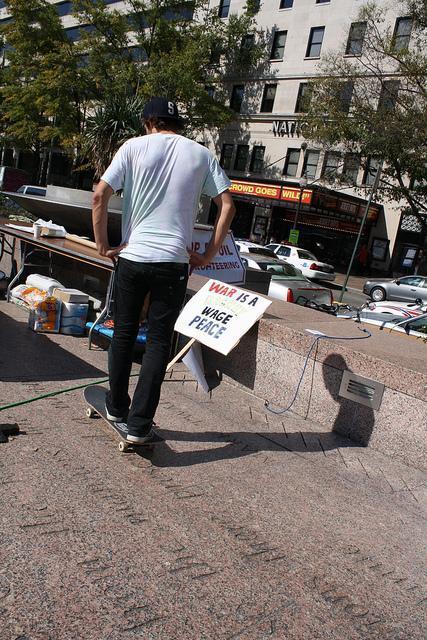How many people are in the photo?
Give a very brief answer. 1. 